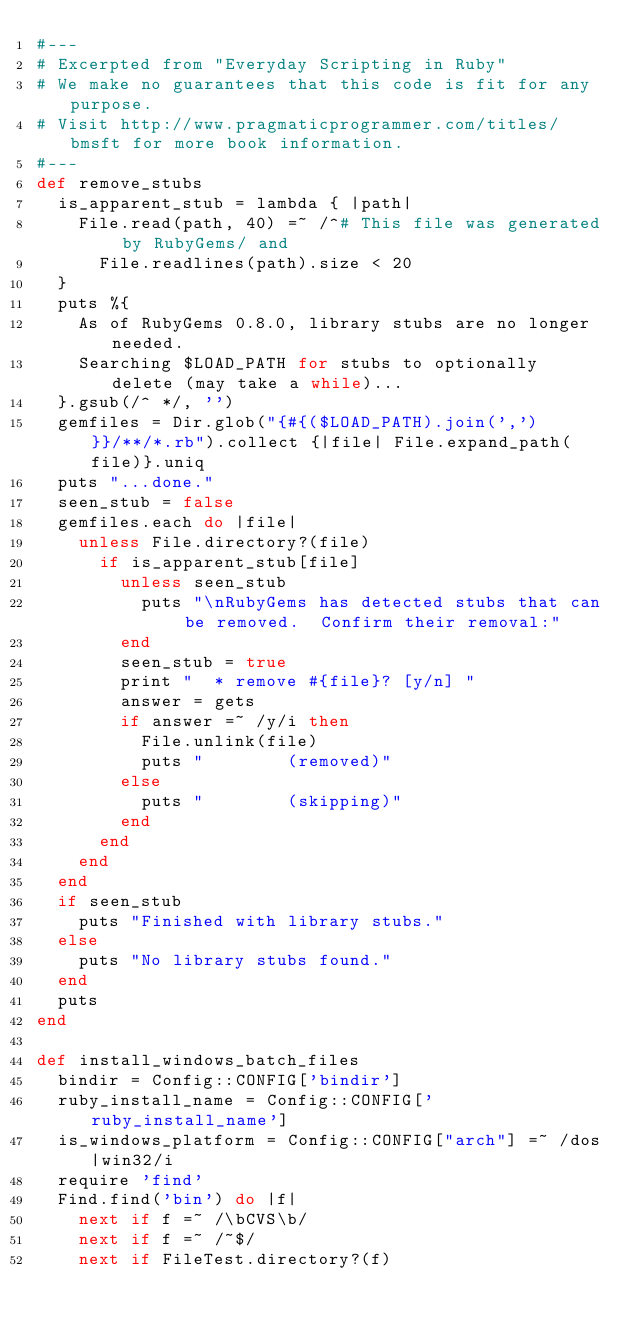Convert code to text. <code><loc_0><loc_0><loc_500><loc_500><_Ruby_>#---
# Excerpted from "Everyday Scripting in Ruby"
# We make no guarantees that this code is fit for any purpose. 
# Visit http://www.pragmaticprogrammer.com/titles/bmsft for more book information.
#---
def remove_stubs
  is_apparent_stub = lambda { |path|
    File.read(path, 40) =~ /^# This file was generated by RubyGems/ and
      File.readlines(path).size < 20
  }
  puts %{
    As of RubyGems 0.8.0, library stubs are no longer needed.
    Searching $LOAD_PATH for stubs to optionally delete (may take a while)...
  }.gsub(/^ */, '')
  gemfiles = Dir.glob("{#{($LOAD_PATH).join(',')}}/**/*.rb").collect {|file| File.expand_path(file)}.uniq
  puts "...done."
  seen_stub = false
  gemfiles.each do |file|
    unless File.directory?(file)
      if is_apparent_stub[file]
        unless seen_stub
          puts "\nRubyGems has detected stubs that can be removed.  Confirm their removal:"
        end
        seen_stub = true
        print "  * remove #{file}? [y/n] "
        answer = gets
        if answer =~ /y/i then
          File.unlink(file)
          puts "        (removed)"
        else
          puts "        (skipping)"
        end
      end
    end
  end
  if seen_stub
    puts "Finished with library stubs."
  else
    puts "No library stubs found."
  end
  puts
end

def install_windows_batch_files
  bindir = Config::CONFIG['bindir']
  ruby_install_name = Config::CONFIG['ruby_install_name']
  is_windows_platform = Config::CONFIG["arch"] =~ /dos|win32/i
  require 'find'
  Find.find('bin') do |f|
    next if f =~ /\bCVS\b/
    next if f =~ /~$/
    next if FileTest.directory?(f)</code> 